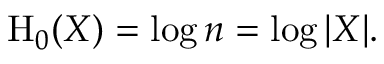Convert formula to latex. <formula><loc_0><loc_0><loc_500><loc_500>H _ { 0 } ( X ) = \log n = \log | X | .</formula> 